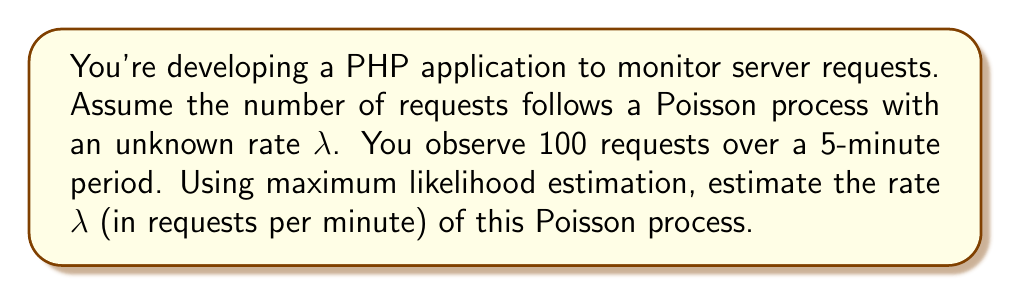Help me with this question. Let's approach this step-by-step:

1) In a Poisson process, the number of events $N(t)$ in a time interval $t$ follows a Poisson distribution with mean $\lambda t$:

   $$P(N(t) = k) = \frac{e^{-\lambda t}(\lambda t)^k}{k!}$$

2) The likelihood function for observing $n$ events in time $t$ is:

   $$L(\lambda) = \frac{e^{-\lambda t}(\lambda t)^n}{n!}$$

3) The log-likelihood function is:

   $$\ln L(\lambda) = -\lambda t + n \ln(\lambda t) - \ln(n!)$$

4) To find the maximum likelihood estimate, we differentiate the log-likelihood with respect to $\lambda$ and set it to zero:

   $$\frac{d}{d\lambda}\ln L(\lambda) = -t + \frac{n}{\lambda} = 0$$

5) Solving this equation:

   $$t = \frac{n}{\lambda}$$
   $$\lambda = \frac{n}{t}$$

6) In our case:
   - $n = 100$ (number of requests)
   - $t = 5$ minutes

7) Plugging in these values:

   $$\lambda = \frac{100}{5} = 20$$

Therefore, the maximum likelihood estimate for $\lambda$ is 20 requests per minute.
Answer: $\lambda = 20$ requests/minute 